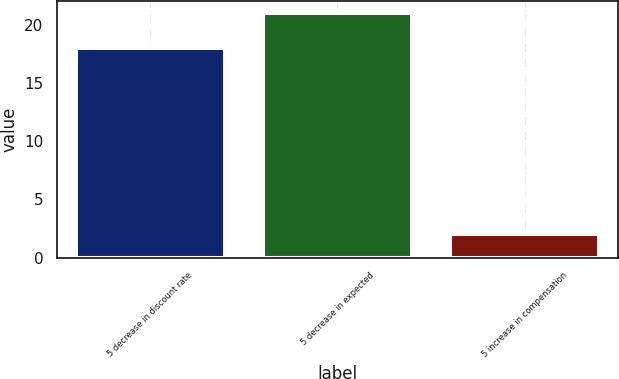Convert chart to OTSL. <chart><loc_0><loc_0><loc_500><loc_500><bar_chart><fcel>5 decrease in discount rate<fcel>5 decrease in expected<fcel>5 increase in compensation<nl><fcel>18<fcel>21<fcel>2<nl></chart> 